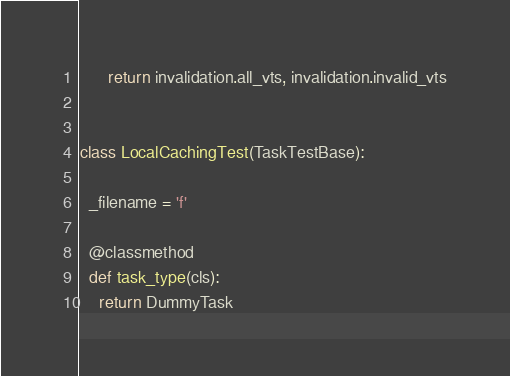Convert code to text. <code><loc_0><loc_0><loc_500><loc_500><_Python_>      return invalidation.all_vts, invalidation.invalid_vts


class LocalCachingTest(TaskTestBase):

  _filename = 'f'

  @classmethod
  def task_type(cls):
    return DummyTask
</code> 